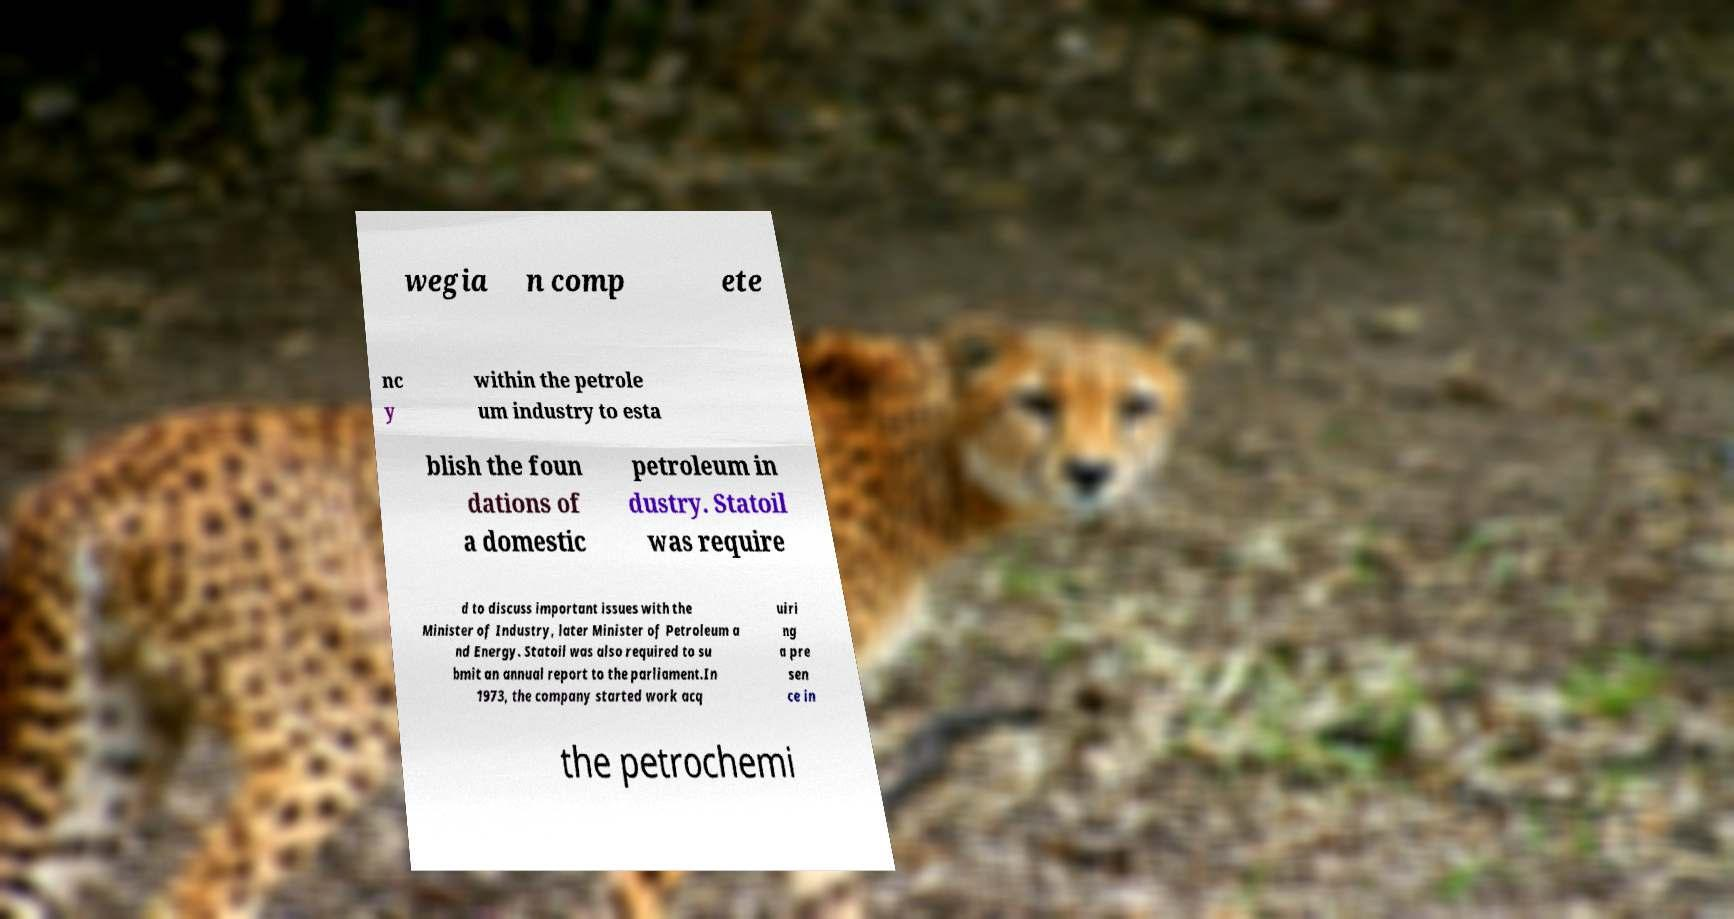Can you accurately transcribe the text from the provided image for me? wegia n comp ete nc y within the petrole um industry to esta blish the foun dations of a domestic petroleum in dustry. Statoil was require d to discuss important issues with the Minister of Industry, later Minister of Petroleum a nd Energy. Statoil was also required to su bmit an annual report to the parliament.In 1973, the company started work acq uiri ng a pre sen ce in the petrochemi 